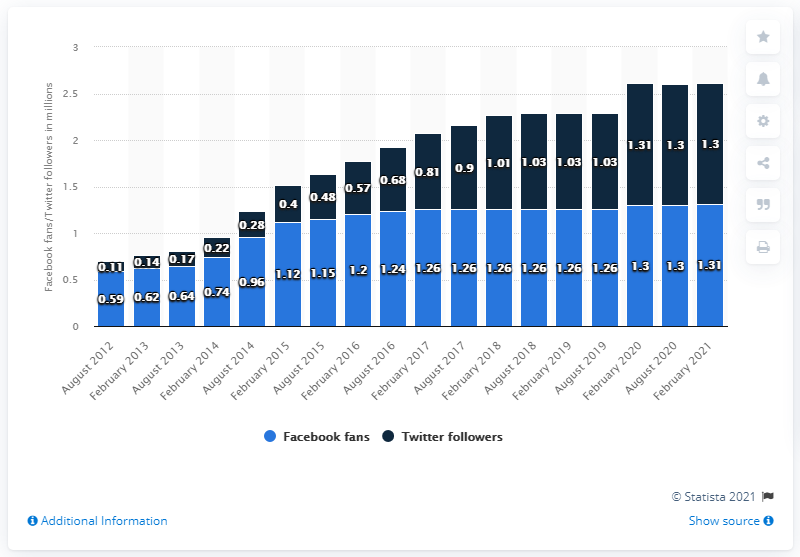Identify some key points in this picture. As of August 2012, the Cleveland Browns had a Facebook page. The Cleveland Browns' Facebook page reached 1.31 million followers in February 2021. In February 2021, the Cleveland Browns football team had 1.31 million Facebook fans. 